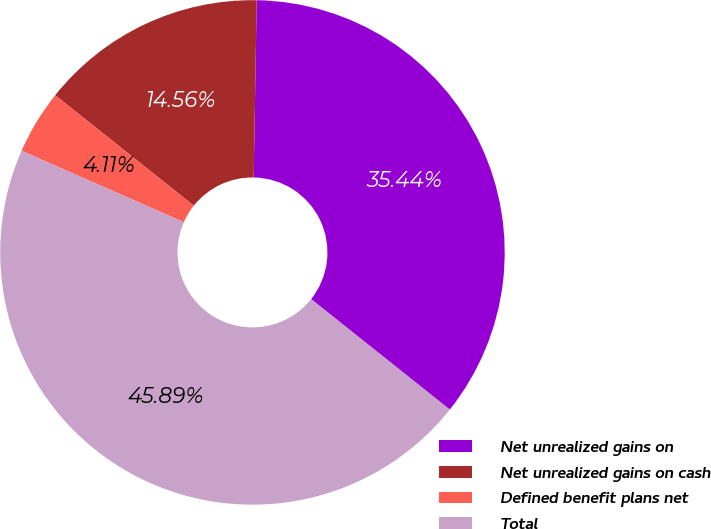<chart> <loc_0><loc_0><loc_500><loc_500><pie_chart><fcel>Net unrealized gains on<fcel>Net unrealized gains on cash<fcel>Defined benefit plans net<fcel>Total<nl><fcel>35.44%<fcel>14.56%<fcel>4.11%<fcel>45.89%<nl></chart> 